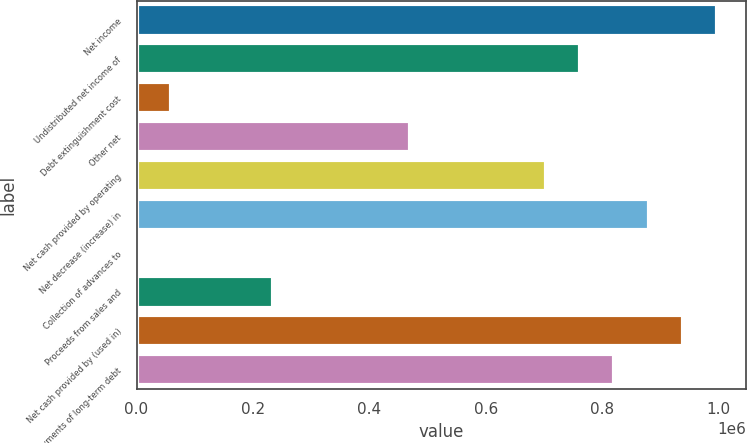Convert chart. <chart><loc_0><loc_0><loc_500><loc_500><bar_chart><fcel>Net income<fcel>Undistributed net income of<fcel>Debt extinguishment cost<fcel>Other net<fcel>Net cash provided by operating<fcel>Net decrease (increase) in<fcel>Collection of advances to<fcel>Proceeds from sales and<fcel>Net cash provided by (used in)<fcel>Repayments of long-term debt<nl><fcel>996947<fcel>762385<fcel>58700.4<fcel>469183<fcel>703745<fcel>879666<fcel>60<fcel>234622<fcel>938306<fcel>821026<nl></chart> 